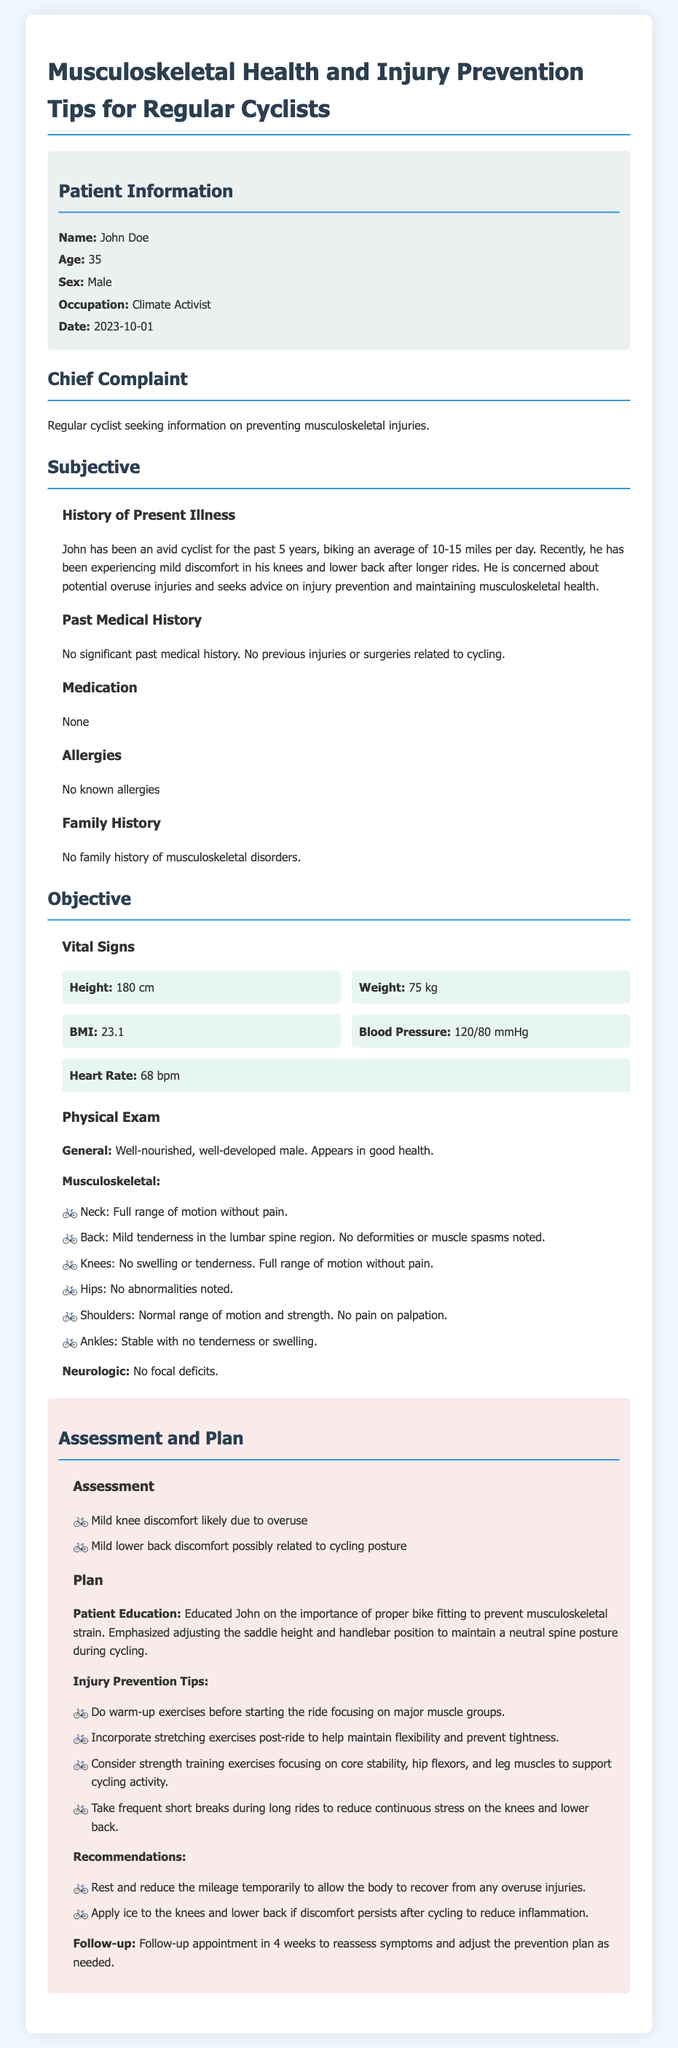what is the patient's name? The patient's name is listed in the patient information section as "John Doe."
Answer: John Doe what is the patient's age? The age of the patient is provided in the patient information section as "35."
Answer: 35 what complaint does John have? John is seeking information on preventing musculoskeletal injuries, as stated in the chief complaint section.
Answer: Preventing musculoskeletal injuries what is John's occupation? John's occupation is mentioned in the patient information section, where it states "Climate Activist."
Answer: Climate Activist how many miles does John bike per day on average? The document states that John bikes an average of "10-15 miles per day."
Answer: 10-15 miles what key factor is emphasized for injury prevention in cyclists? The assessment and plan section emphasizes the importance of "proper bike fitting" to prevent musculoskeletal strain.
Answer: Proper bike fitting what type of exercises does the plan suggest post-ride? The plan recommends incorporating "stretching exercises" post-ride to maintain flexibility.
Answer: Stretching exercises which muscle groups are highlighted for strength training? The document mentions focusing on "core stability, hip flexors, and leg muscles" for strength training.
Answer: Core stability, hip flexors, and leg muscles what is the follow-up time frame after the initial assessment? The follow-up appointment is scheduled for "4 weeks" after the initial assessment.
Answer: 4 weeks 